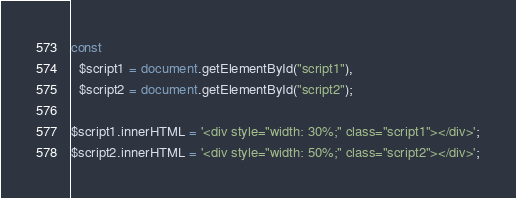Convert code to text. <code><loc_0><loc_0><loc_500><loc_500><_JavaScript_>
const 
  $script1 = document.getElementById("script1"),
  $script2 = document.getElementById("script2");

$script1.innerHTML = '<div style="width: 30%;" class="script1"></div>';
$script2.innerHTML = '<div style="width: 50%;" class="script2"></div>';


</code> 